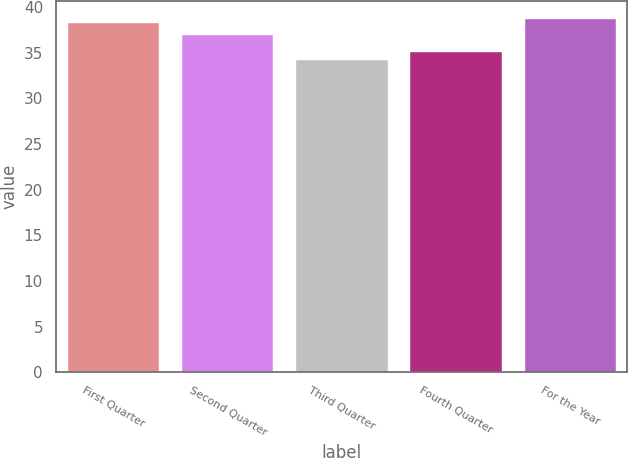Convert chart to OTSL. <chart><loc_0><loc_0><loc_500><loc_500><bar_chart><fcel>First Quarter<fcel>Second Quarter<fcel>Third Quarter<fcel>Fourth Quarter<fcel>For the Year<nl><fcel>38.3<fcel>36.99<fcel>34.24<fcel>35.1<fcel>38.71<nl></chart> 